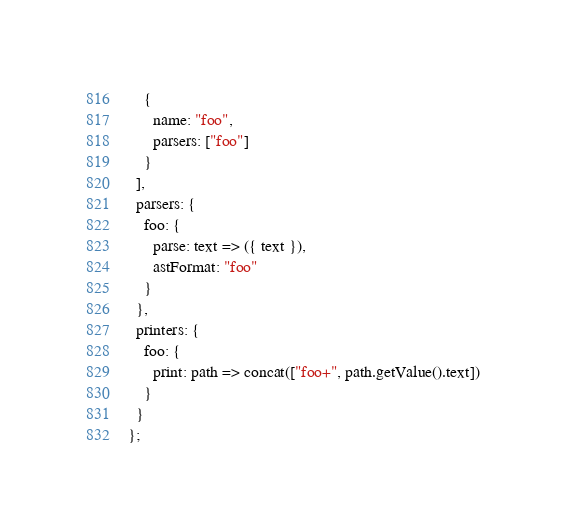Convert code to text. <code><loc_0><loc_0><loc_500><loc_500><_JavaScript_>    {
      name: "foo",
      parsers: ["foo"]
    }
  ],
  parsers: {
    foo: {
      parse: text => ({ text }),
      astFormat: "foo"
    }
  },
  printers: {
    foo: {
      print: path => concat(["foo+", path.getValue().text])
    }
  }
};
</code> 